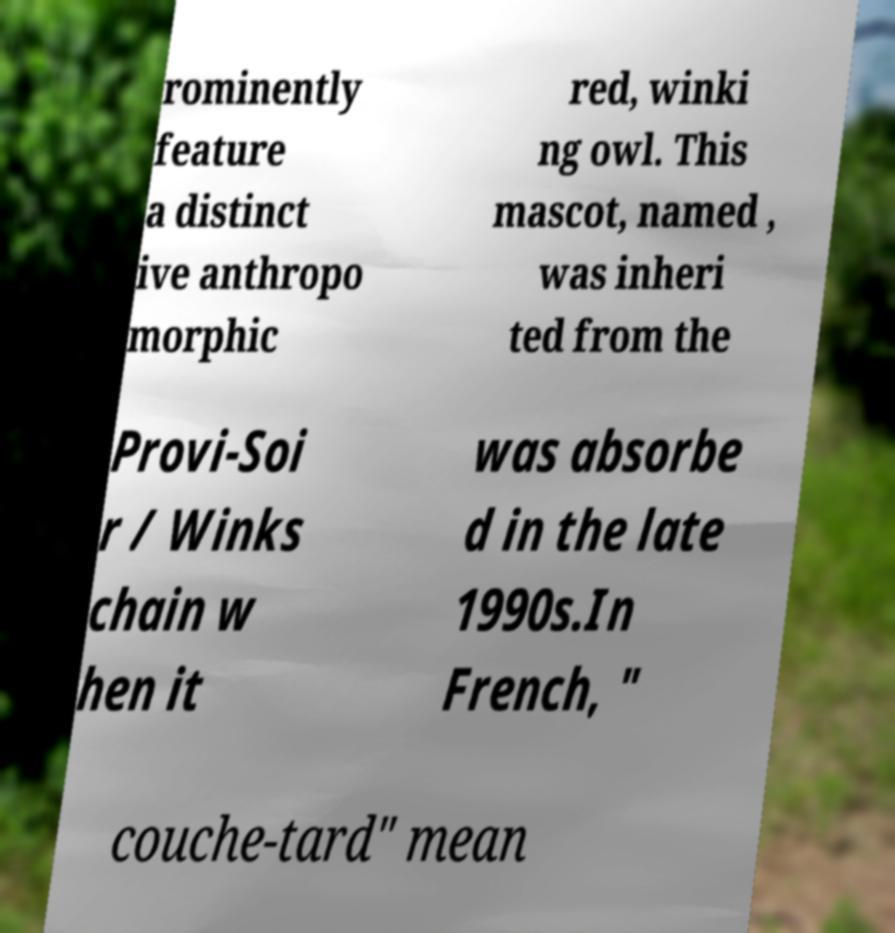Please read and relay the text visible in this image. What does it say? rominently feature a distinct ive anthropo morphic red, winki ng owl. This mascot, named , was inheri ted from the Provi-Soi r / Winks chain w hen it was absorbe d in the late 1990s.In French, " couche-tard" mean 